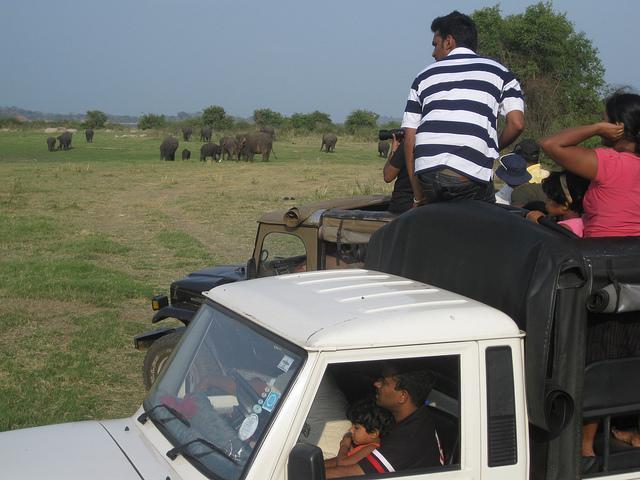How many people are visible?
Give a very brief answer. 5. How many of the buses visible on the street are two story?
Give a very brief answer. 0. 